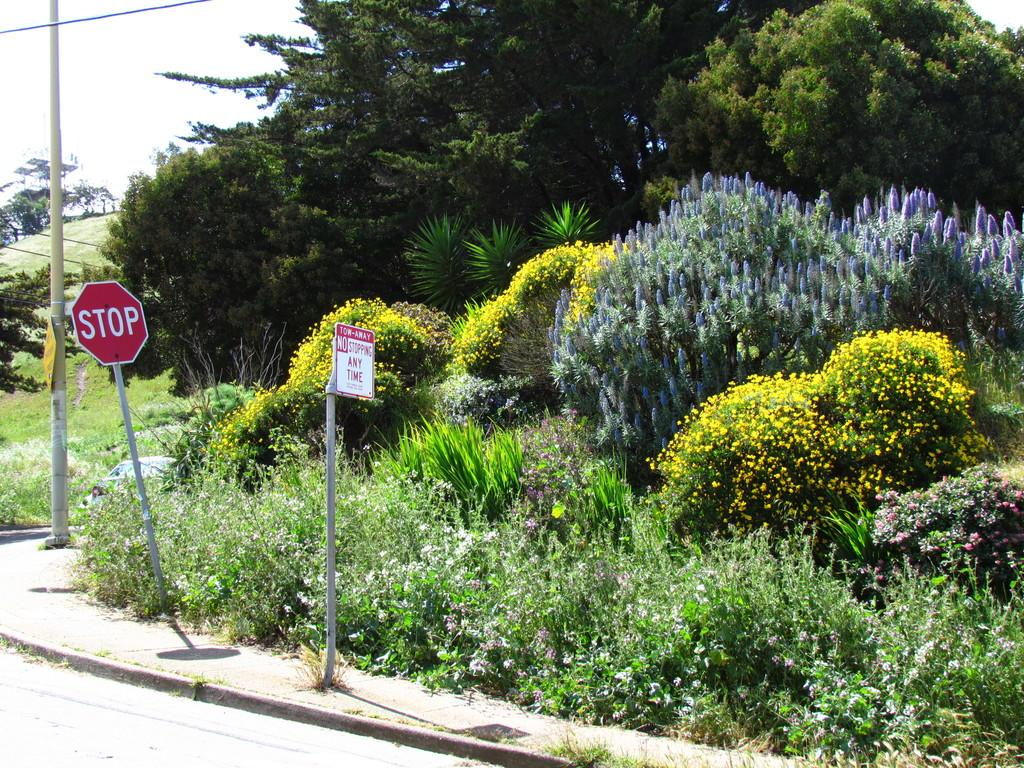What type of vegetation can be seen in the image? There are trees, plants, and flowers in the image. What other objects can be seen in the image besides vegetation? There are boards and a pole in the image. What is the ground surface like in the image? There is a road at the bottom of the image. How many boats are visible in the image? There are no boats present in the image. What type of comb is being used to groom the plants in the image? There is no comb present in the image, and the plants do not require grooming. 